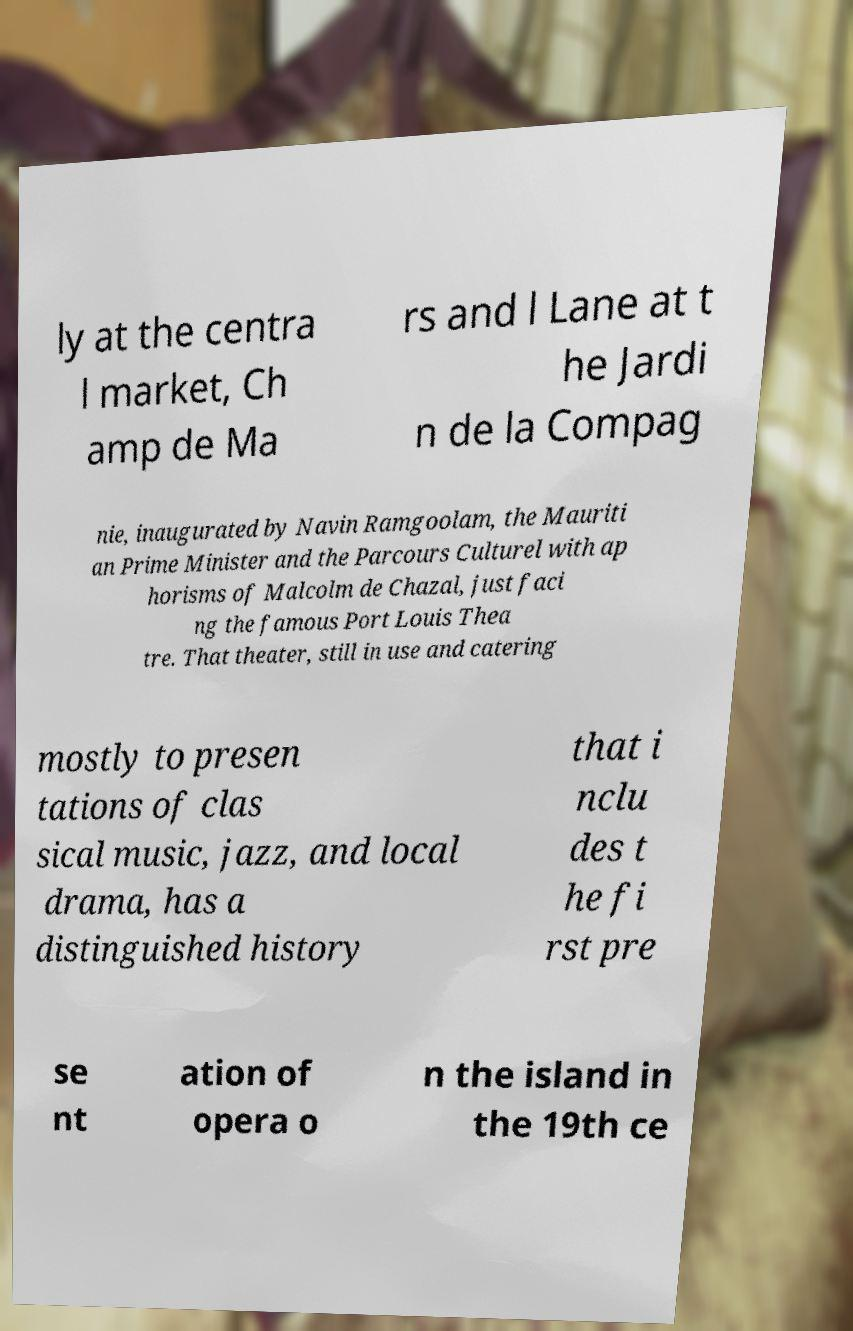Can you accurately transcribe the text from the provided image for me? ly at the centra l market, Ch amp de Ma rs and l Lane at t he Jardi n de la Compag nie, inaugurated by Navin Ramgoolam, the Mauriti an Prime Minister and the Parcours Culturel with ap horisms of Malcolm de Chazal, just faci ng the famous Port Louis Thea tre. That theater, still in use and catering mostly to presen tations of clas sical music, jazz, and local drama, has a distinguished history that i nclu des t he fi rst pre se nt ation of opera o n the island in the 19th ce 